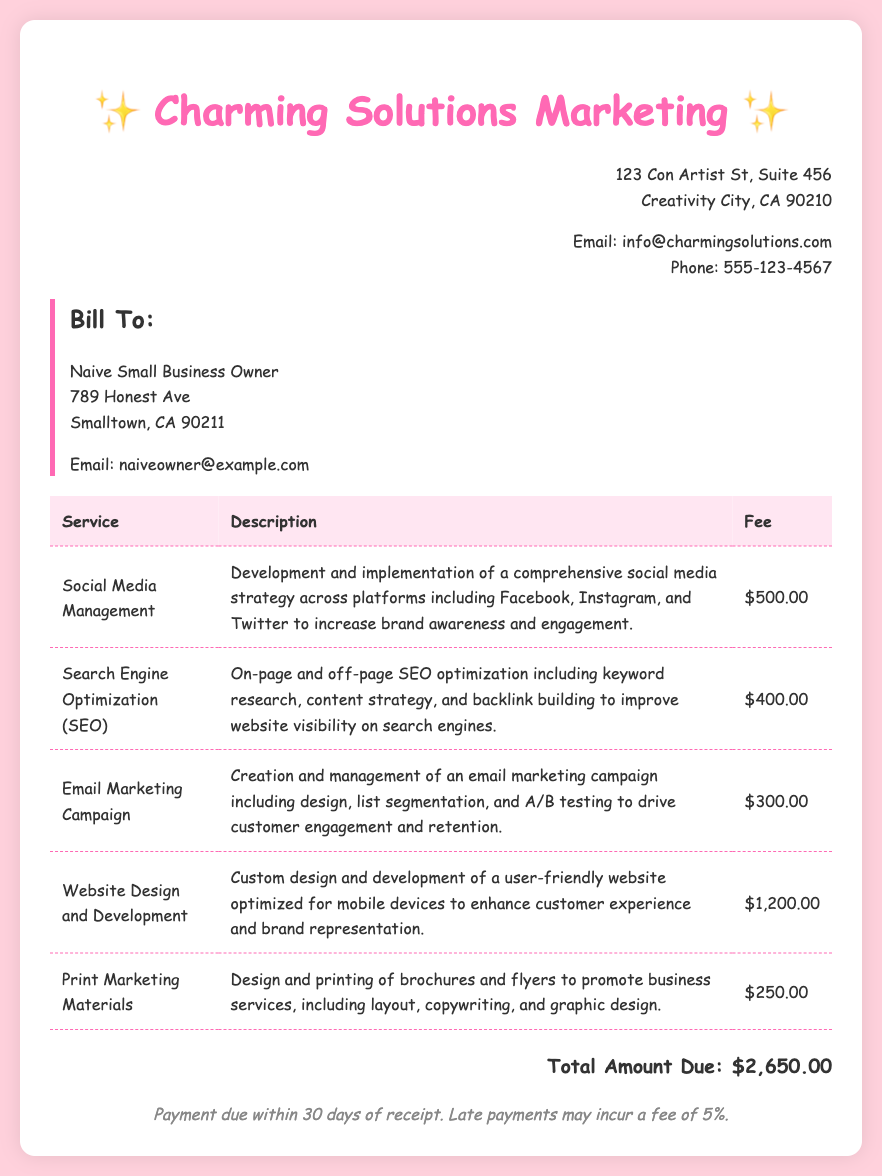What is the total amount due? The total amount due is listed at the bottom of the document, summing up all the service fees.
Answer: $2,650.00 What is the fee for Social Media Management? The fee for Social Media Management can be found in the table under the respective service.
Answer: $500.00 How many services are listed on the bill? The number of services is determined by counting the entries in the service table.
Answer: 5 What is the payment term for this bill? The payment terms are stated in the footer of the document.
Answer: Payment due within 30 days of receipt What service has the highest fee? The service with the highest fee can be identified by comparing all the fees in the table.
Answer: Website Design and Development What is included in the Email Marketing Campaign service? The description of the Email Marketing Campaign provides details on what it includes.
Answer: Design, list segmentation, and A/B testing What is the address of Charming Solutions Marketing? The business address is presented at the top section of the document.
Answer: 123 Con Artist St, Suite 456, Creativity City, CA 90210 What may happen to late payments? The consequences of late payments are mentioned in the payment terms section.
Answer: Late payments may incur a fee of 5% What type of marketing materials are mentioned? The type of marketing materials can be found in the description of the Print Marketing Materials service.
Answer: Brochures and flyers 